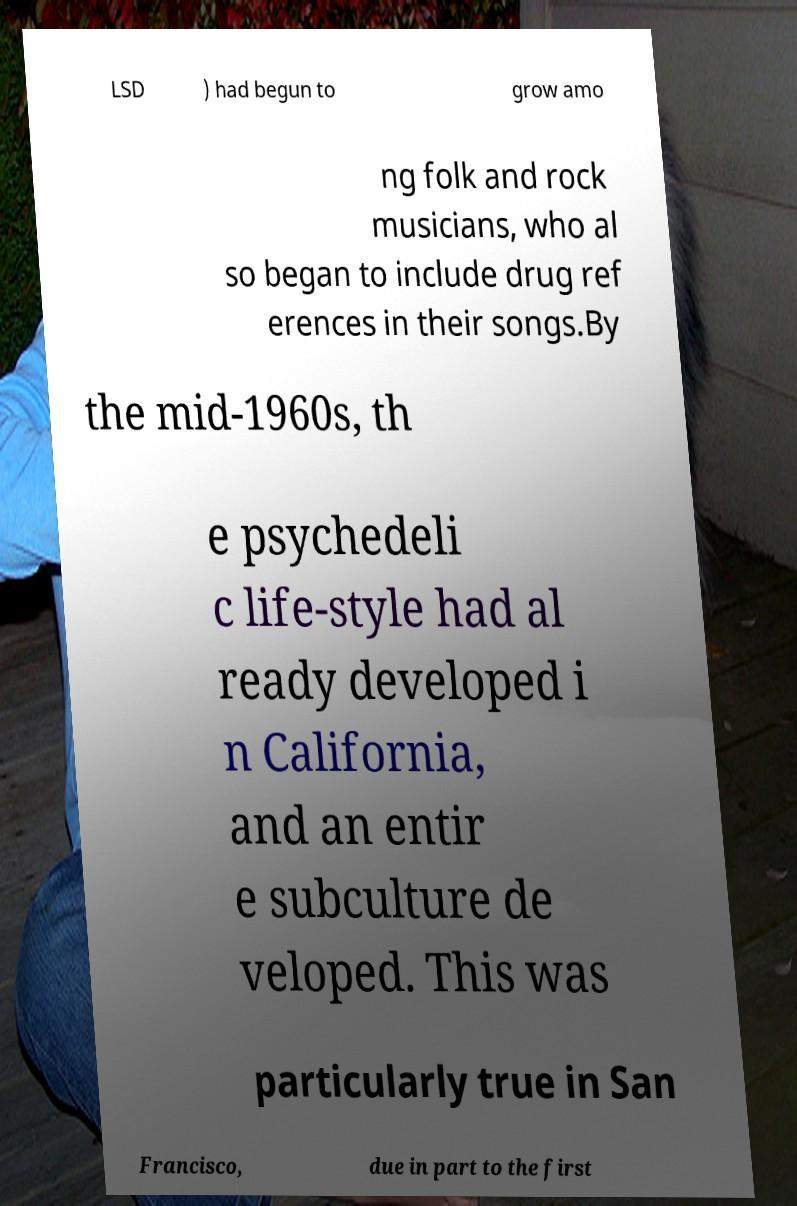Please read and relay the text visible in this image. What does it say? LSD ) had begun to grow amo ng folk and rock musicians, who al so began to include drug ref erences in their songs.By the mid-1960s, th e psychedeli c life-style had al ready developed i n California, and an entir e subculture de veloped. This was particularly true in San Francisco, due in part to the first 